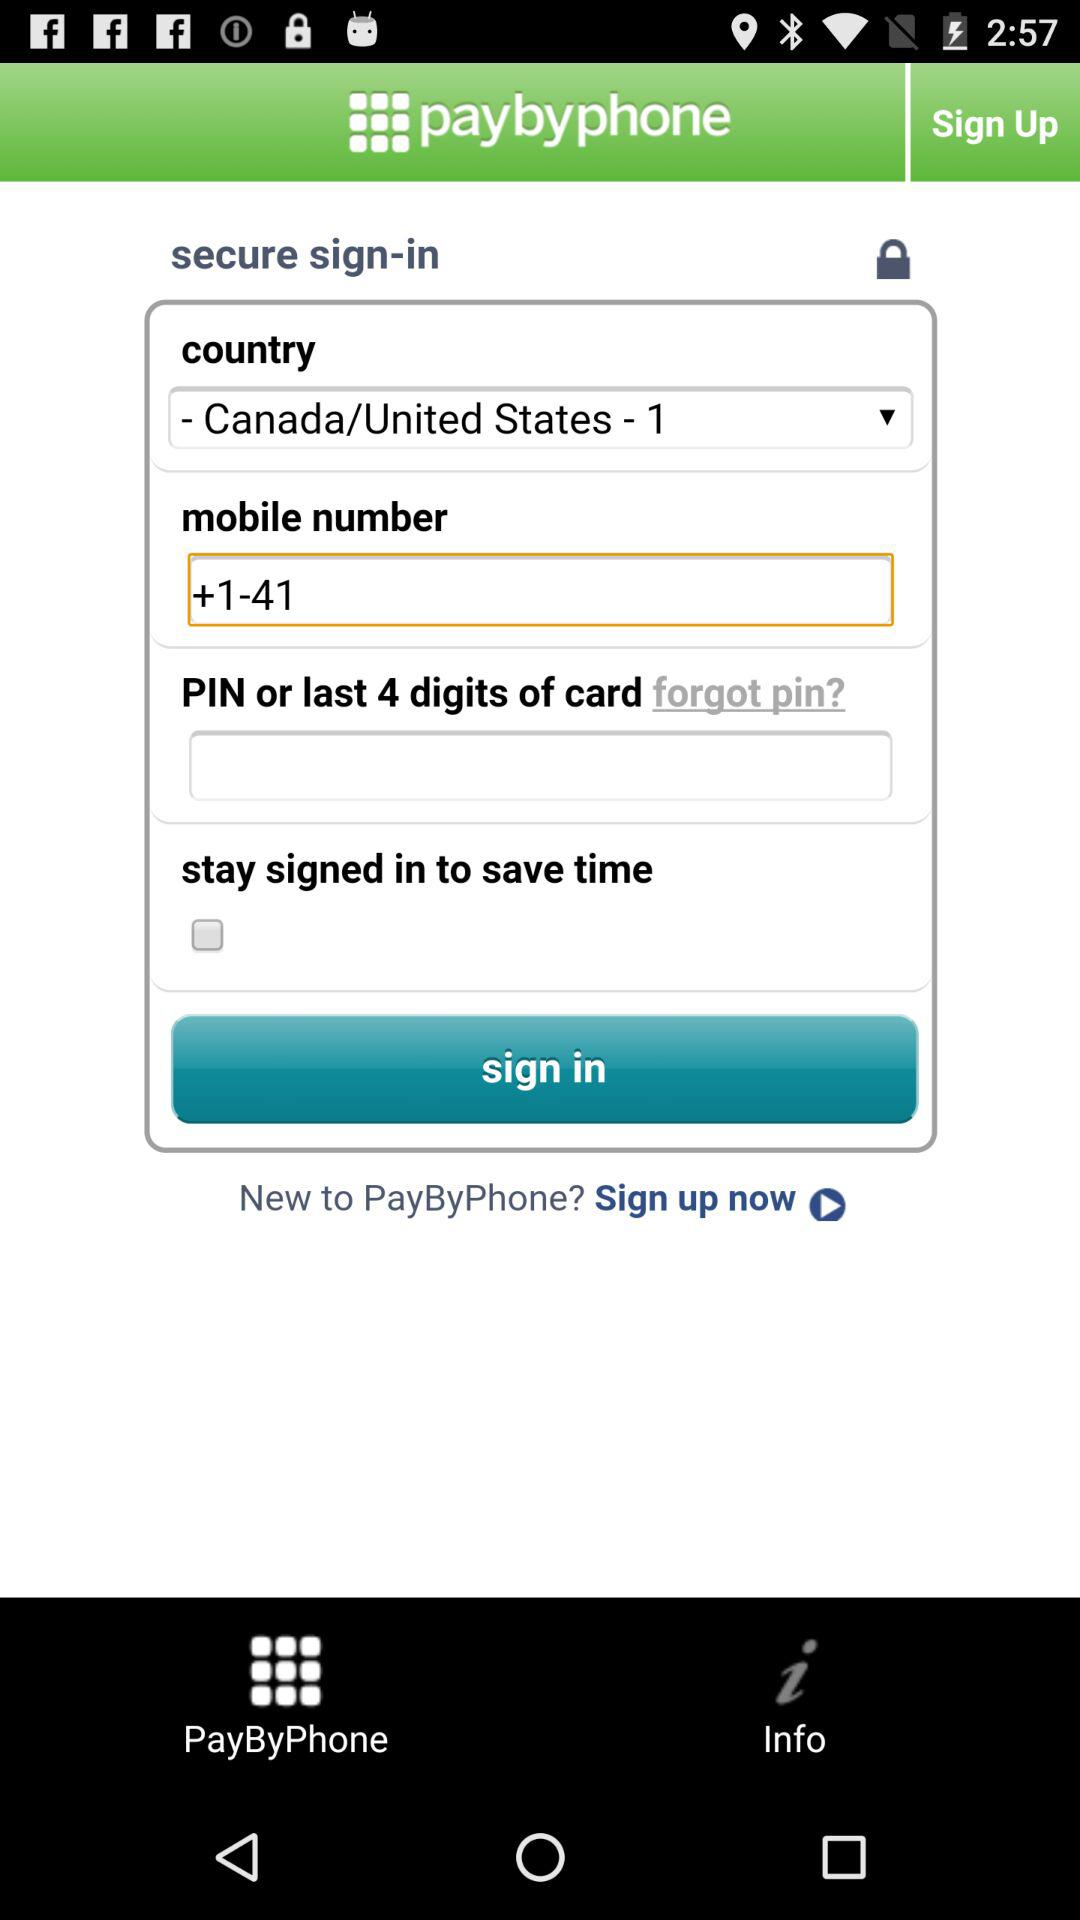What is the country name? The country name is Canada/United States-1. 